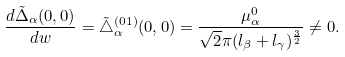Convert formula to latex. <formula><loc_0><loc_0><loc_500><loc_500>\frac { d \tilde { \Delta } _ { \alpha } ( 0 , 0 ) } { d w } = \tilde { \triangle } ^ { ( 0 1 ) } _ { \alpha } ( 0 , 0 ) = \frac { \mu _ { \alpha } ^ { 0 } } { \sqrt { 2 } \pi ( l _ { \beta } + l _ { \gamma } ) ^ { \frac { 3 } { 2 } } } \neq 0 .</formula> 